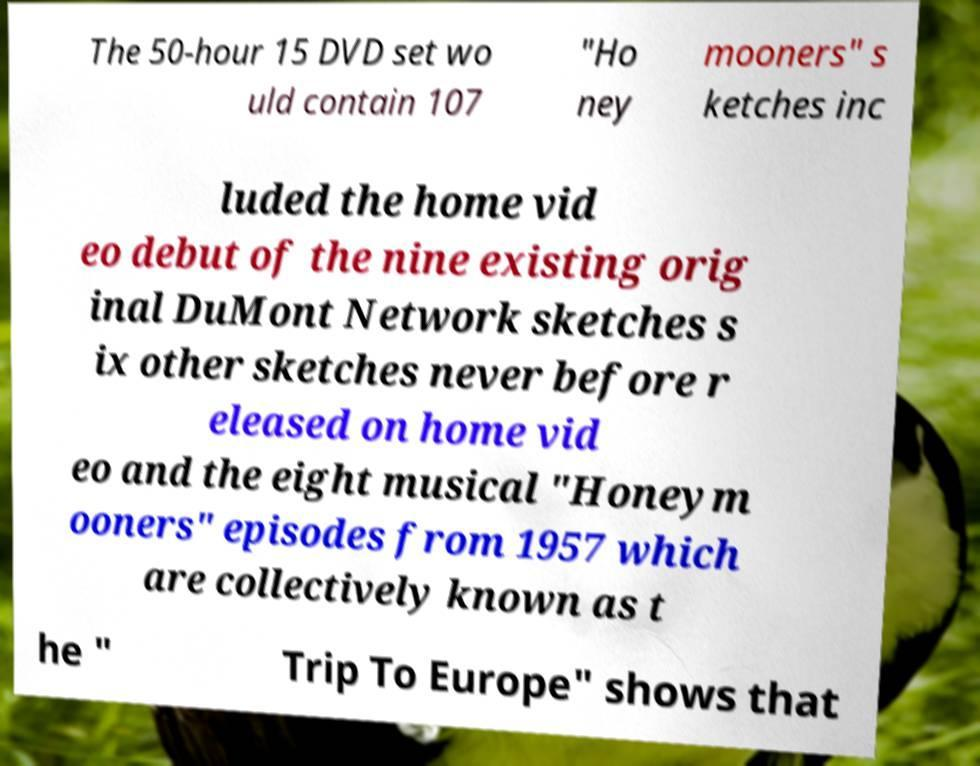I need the written content from this picture converted into text. Can you do that? The 50-hour 15 DVD set wo uld contain 107 "Ho ney mooners" s ketches inc luded the home vid eo debut of the nine existing orig inal DuMont Network sketches s ix other sketches never before r eleased on home vid eo and the eight musical "Honeym ooners" episodes from 1957 which are collectively known as t he " Trip To Europe" shows that 